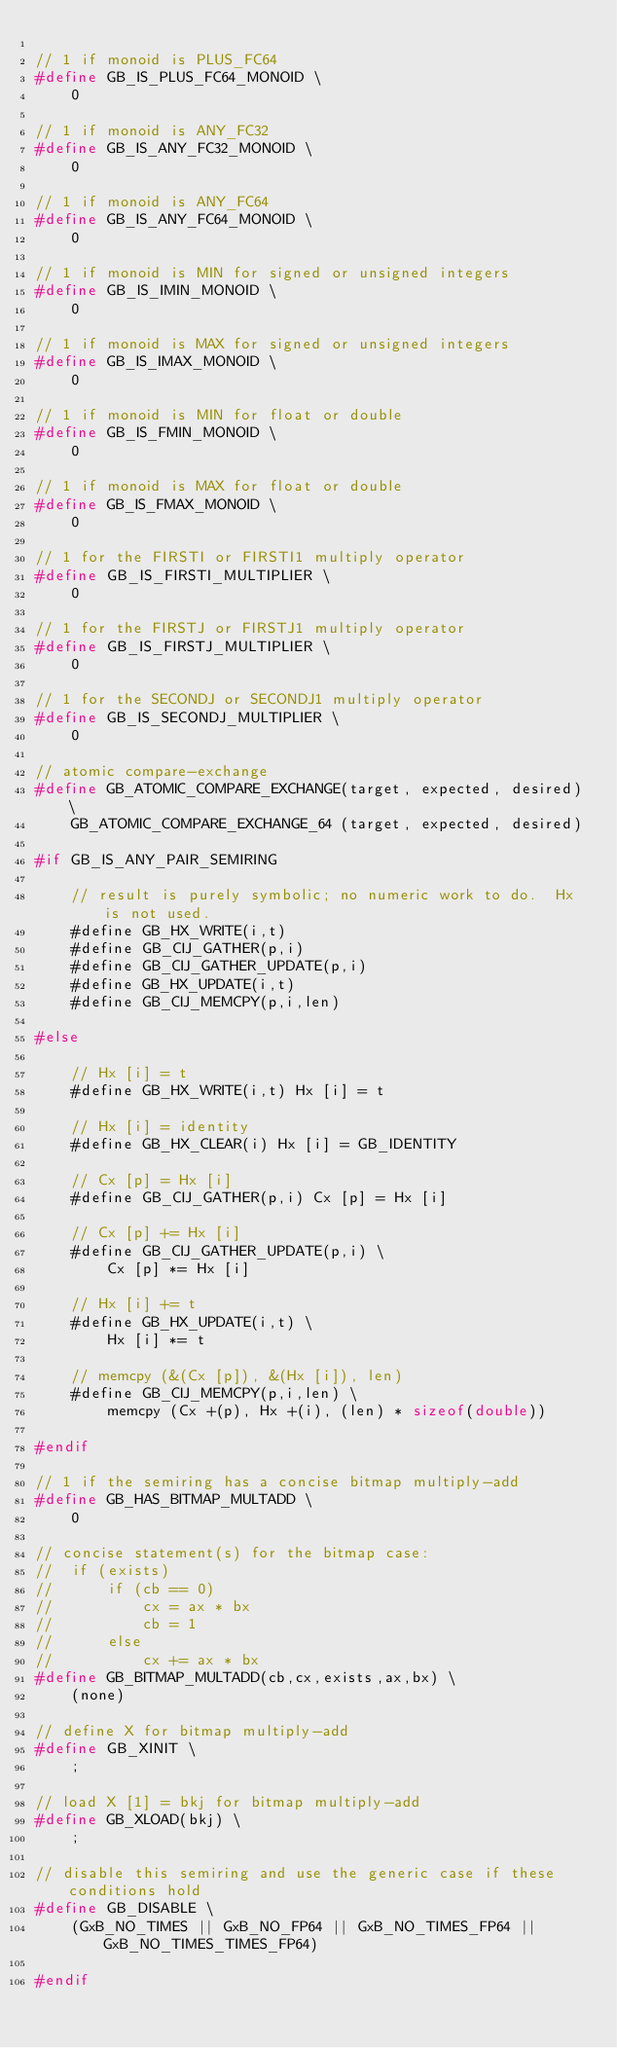Convert code to text. <code><loc_0><loc_0><loc_500><loc_500><_C_>
// 1 if monoid is PLUS_FC64
#define GB_IS_PLUS_FC64_MONOID \
    0

// 1 if monoid is ANY_FC32
#define GB_IS_ANY_FC32_MONOID \
    0

// 1 if monoid is ANY_FC64
#define GB_IS_ANY_FC64_MONOID \
    0

// 1 if monoid is MIN for signed or unsigned integers
#define GB_IS_IMIN_MONOID \
    0

// 1 if monoid is MAX for signed or unsigned integers
#define GB_IS_IMAX_MONOID \
    0

// 1 if monoid is MIN for float or double
#define GB_IS_FMIN_MONOID \
    0

// 1 if monoid is MAX for float or double
#define GB_IS_FMAX_MONOID \
    0

// 1 for the FIRSTI or FIRSTI1 multiply operator
#define GB_IS_FIRSTI_MULTIPLIER \
    0

// 1 for the FIRSTJ or FIRSTJ1 multiply operator
#define GB_IS_FIRSTJ_MULTIPLIER \
    0

// 1 for the SECONDJ or SECONDJ1 multiply operator
#define GB_IS_SECONDJ_MULTIPLIER \
    0

// atomic compare-exchange
#define GB_ATOMIC_COMPARE_EXCHANGE(target, expected, desired) \
    GB_ATOMIC_COMPARE_EXCHANGE_64 (target, expected, desired)

#if GB_IS_ANY_PAIR_SEMIRING

    // result is purely symbolic; no numeric work to do.  Hx is not used.
    #define GB_HX_WRITE(i,t)
    #define GB_CIJ_GATHER(p,i)
    #define GB_CIJ_GATHER_UPDATE(p,i)
    #define GB_HX_UPDATE(i,t)
    #define GB_CIJ_MEMCPY(p,i,len)

#else

    // Hx [i] = t
    #define GB_HX_WRITE(i,t) Hx [i] = t

    // Hx [i] = identity
    #define GB_HX_CLEAR(i) Hx [i] = GB_IDENTITY

    // Cx [p] = Hx [i]
    #define GB_CIJ_GATHER(p,i) Cx [p] = Hx [i]

    // Cx [p] += Hx [i]
    #define GB_CIJ_GATHER_UPDATE(p,i) \
        Cx [p] *= Hx [i]

    // Hx [i] += t
    #define GB_HX_UPDATE(i,t) \
        Hx [i] *= t

    // memcpy (&(Cx [p]), &(Hx [i]), len)
    #define GB_CIJ_MEMCPY(p,i,len) \
        memcpy (Cx +(p), Hx +(i), (len) * sizeof(double))

#endif

// 1 if the semiring has a concise bitmap multiply-add
#define GB_HAS_BITMAP_MULTADD \
    0

// concise statement(s) for the bitmap case:
//  if (exists)
//      if (cb == 0)
//          cx = ax * bx
//          cb = 1
//      else
//          cx += ax * bx
#define GB_BITMAP_MULTADD(cb,cx,exists,ax,bx) \
    (none)

// define X for bitmap multiply-add
#define GB_XINIT \
    ;

// load X [1] = bkj for bitmap multiply-add
#define GB_XLOAD(bkj) \
    ;

// disable this semiring and use the generic case if these conditions hold
#define GB_DISABLE \
    (GxB_NO_TIMES || GxB_NO_FP64 || GxB_NO_TIMES_FP64 || GxB_NO_TIMES_TIMES_FP64)

#endif

</code> 